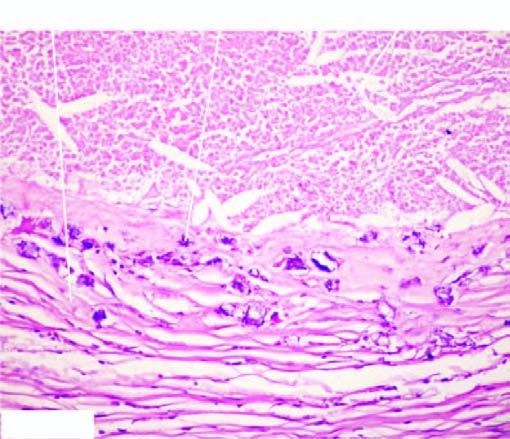re defects in any of the six basophilic granular while the periphery shows healed granulomas?
Answer the question using a single word or phrase. No 